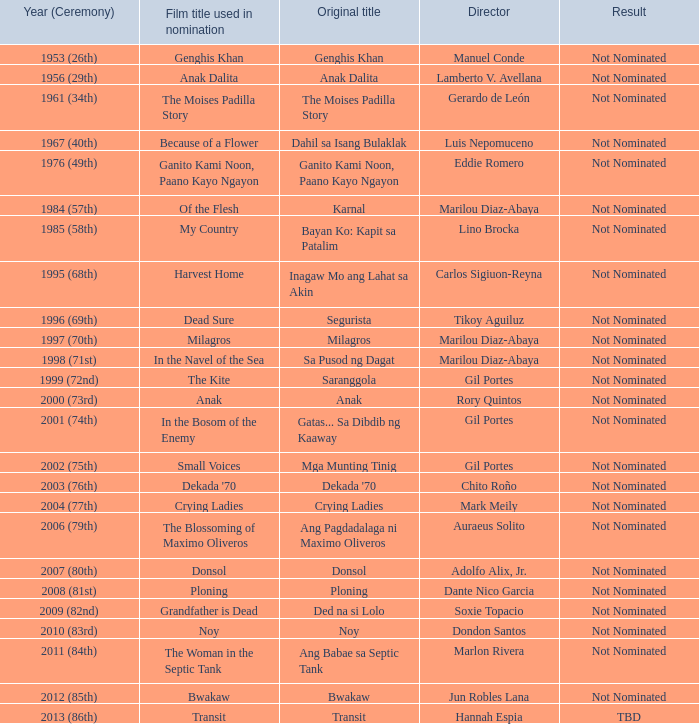Write the full table. {'header': ['Year (Ceremony)', 'Film title used in nomination', 'Original title', 'Director', 'Result'], 'rows': [['1953 (26th)', 'Genghis Khan', 'Genghis Khan', 'Manuel Conde', 'Not Nominated'], ['1956 (29th)', 'Anak Dalita', 'Anak Dalita', 'Lamberto V. Avellana', 'Not Nominated'], ['1961 (34th)', 'The Moises Padilla Story', 'The Moises Padilla Story', 'Gerardo de León', 'Not Nominated'], ['1967 (40th)', 'Because of a Flower', 'Dahil sa Isang Bulaklak', 'Luis Nepomuceno', 'Not Nominated'], ['1976 (49th)', 'Ganito Kami Noon, Paano Kayo Ngayon', 'Ganito Kami Noon, Paano Kayo Ngayon', 'Eddie Romero', 'Not Nominated'], ['1984 (57th)', 'Of the Flesh', 'Karnal', 'Marilou Diaz-Abaya', 'Not Nominated'], ['1985 (58th)', 'My Country', 'Bayan Ko: Kapit sa Patalim', 'Lino Brocka', 'Not Nominated'], ['1995 (68th)', 'Harvest Home', 'Inagaw Mo ang Lahat sa Akin', 'Carlos Sigiuon-Reyna', 'Not Nominated'], ['1996 (69th)', 'Dead Sure', 'Segurista', 'Tikoy Aguiluz', 'Not Nominated'], ['1997 (70th)', 'Milagros', 'Milagros', 'Marilou Diaz-Abaya', 'Not Nominated'], ['1998 (71st)', 'In the Navel of the Sea', 'Sa Pusod ng Dagat', 'Marilou Diaz-Abaya', 'Not Nominated'], ['1999 (72nd)', 'The Kite', 'Saranggola', 'Gil Portes', 'Not Nominated'], ['2000 (73rd)', 'Anak', 'Anak', 'Rory Quintos', 'Not Nominated'], ['2001 (74th)', 'In the Bosom of the Enemy', 'Gatas... Sa Dibdib ng Kaaway', 'Gil Portes', 'Not Nominated'], ['2002 (75th)', 'Small Voices', 'Mga Munting Tinig', 'Gil Portes', 'Not Nominated'], ['2003 (76th)', "Dekada '70", "Dekada '70", 'Chito Roño', 'Not Nominated'], ['2004 (77th)', 'Crying Ladies', 'Crying Ladies', 'Mark Meily', 'Not Nominated'], ['2006 (79th)', 'The Blossoming of Maximo Oliveros', 'Ang Pagdadalaga ni Maximo Oliveros', 'Auraeus Solito', 'Not Nominated'], ['2007 (80th)', 'Donsol', 'Donsol', 'Adolfo Alix, Jr.', 'Not Nominated'], ['2008 (81st)', 'Ploning', 'Ploning', 'Dante Nico Garcia', 'Not Nominated'], ['2009 (82nd)', 'Grandfather is Dead', 'Ded na si Lolo', 'Soxie Topacio', 'Not Nominated'], ['2010 (83rd)', 'Noy', 'Noy', 'Dondon Santos', 'Not Nominated'], ['2011 (84th)', 'The Woman in the Septic Tank', 'Ang Babae sa Septic Tank', 'Marlon Rivera', 'Not Nominated'], ['2012 (85th)', 'Bwakaw', 'Bwakaw', 'Jun Robles Lana', 'Not Nominated'], ['2013 (86th)', 'Transit', 'Transit', 'Hannah Espia', 'TBD']]} Which year had in the navel of the sea as the film title in nomination, yet the consequence was not being nominated? 1998 (71st). 